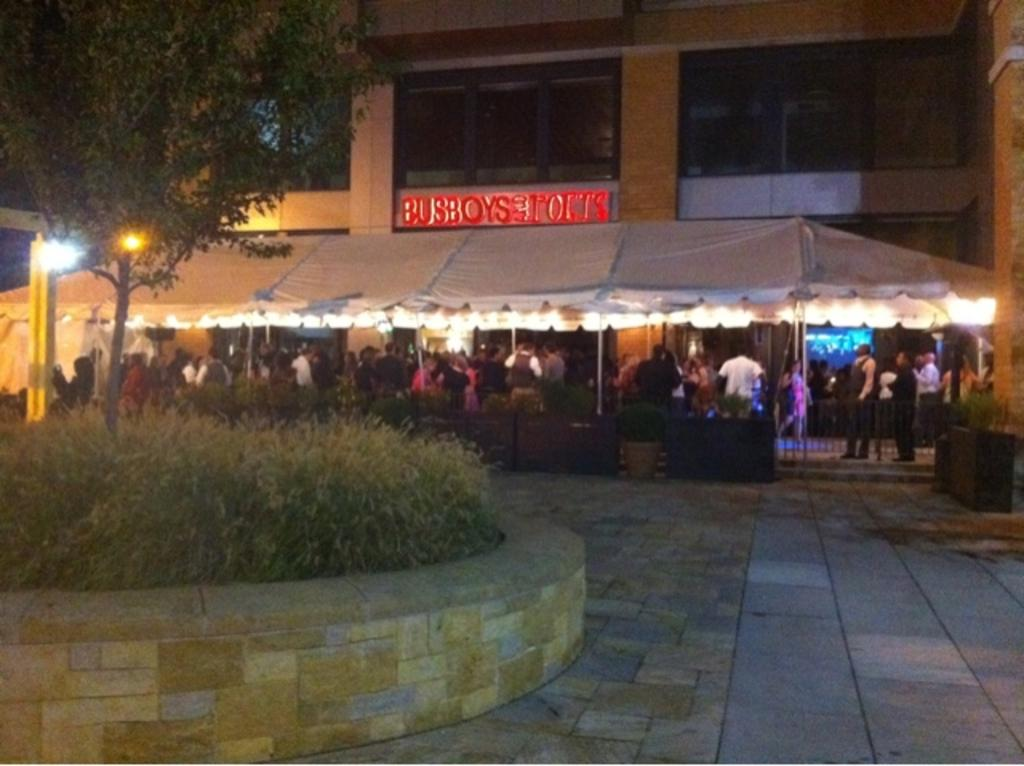What type of structure is present in the image? There is a building in the image. Can you describe any text or signage on the building? Yes, there is text visible on the building. What is located in front of the building? There is a tent in front of the building. Are there any people present in the image? Yes, there are people in the image. What type of lighting is visible in the image? There are lights in the image. What type of vegetation is present in the image? There is grass in the image. What type of support structures are present in the image? There are poles in the image. What type of barrier is present in the image? There is a fence in the image. What type of screw is holding the idea together in the image? There is no mention of a screw or an idea in the image; it features a building, a tent, people, lights, grass, poles, and a fence. 